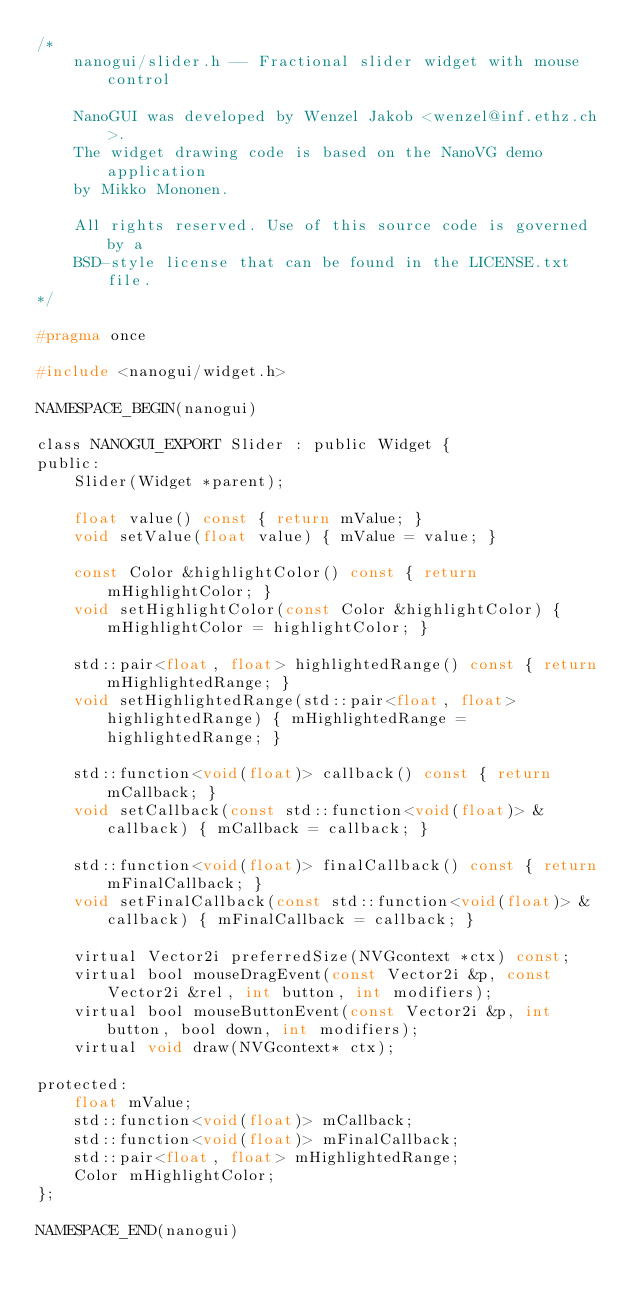Convert code to text. <code><loc_0><loc_0><loc_500><loc_500><_C_>/*
    nanogui/slider.h -- Fractional slider widget with mouse control

    NanoGUI was developed by Wenzel Jakob <wenzel@inf.ethz.ch>.
    The widget drawing code is based on the NanoVG demo application
    by Mikko Mononen.

    All rights reserved. Use of this source code is governed by a
    BSD-style license that can be found in the LICENSE.txt file.
*/

#pragma once

#include <nanogui/widget.h>

NAMESPACE_BEGIN(nanogui)

class NANOGUI_EXPORT Slider : public Widget {
public:
    Slider(Widget *parent);

    float value() const { return mValue; }
    void setValue(float value) { mValue = value; }

    const Color &highlightColor() const { return mHighlightColor; }
    void setHighlightColor(const Color &highlightColor) { mHighlightColor = highlightColor; }

    std::pair<float, float> highlightedRange() const { return mHighlightedRange; }
    void setHighlightedRange(std::pair<float, float> highlightedRange) { mHighlightedRange = highlightedRange; }

    std::function<void(float)> callback() const { return mCallback; }
    void setCallback(const std::function<void(float)> &callback) { mCallback = callback; }

    std::function<void(float)> finalCallback() const { return mFinalCallback; }
    void setFinalCallback(const std::function<void(float)> &callback) { mFinalCallback = callback; }

    virtual Vector2i preferredSize(NVGcontext *ctx) const;
    virtual bool mouseDragEvent(const Vector2i &p, const Vector2i &rel, int button, int modifiers);
    virtual bool mouseButtonEvent(const Vector2i &p, int button, bool down, int modifiers);
    virtual void draw(NVGcontext* ctx);

protected:
    float mValue;
    std::function<void(float)> mCallback;
    std::function<void(float)> mFinalCallback;
    std::pair<float, float> mHighlightedRange;
    Color mHighlightColor;
};

NAMESPACE_END(nanogui)
</code> 